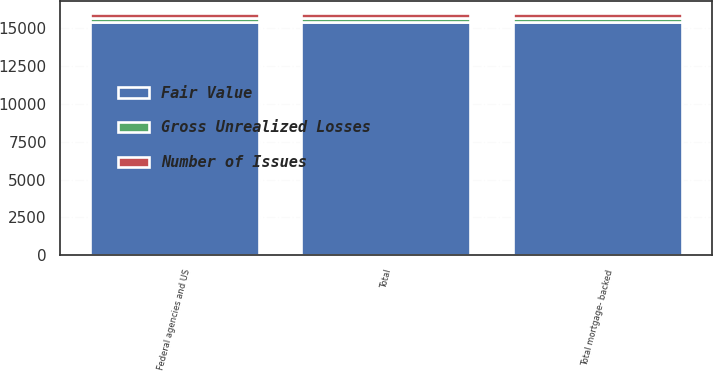Convert chart to OTSL. <chart><loc_0><loc_0><loc_500><loc_500><stacked_bar_chart><ecel><fcel>Federal agencies and US<fcel>Total mortgage- backed<fcel>Total<nl><fcel>Number of Issues<fcel>323<fcel>327<fcel>328<nl><fcel>Fair Value<fcel>15387<fcel>15395<fcel>15403<nl><fcel>Gross Unrealized Losses<fcel>292<fcel>292<fcel>292<nl></chart> 